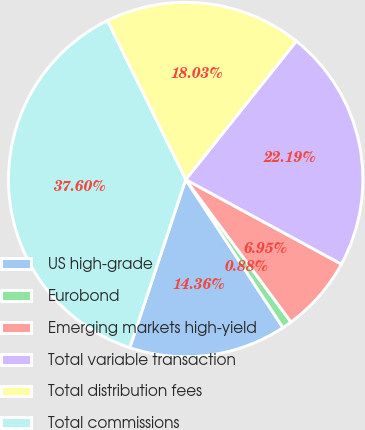Convert chart. <chart><loc_0><loc_0><loc_500><loc_500><pie_chart><fcel>US high-grade<fcel>Eurobond<fcel>Emerging markets high-yield<fcel>Total variable transaction<fcel>Total distribution fees<fcel>Total commissions<nl><fcel>14.36%<fcel>0.88%<fcel>6.95%<fcel>22.19%<fcel>18.03%<fcel>37.6%<nl></chart> 